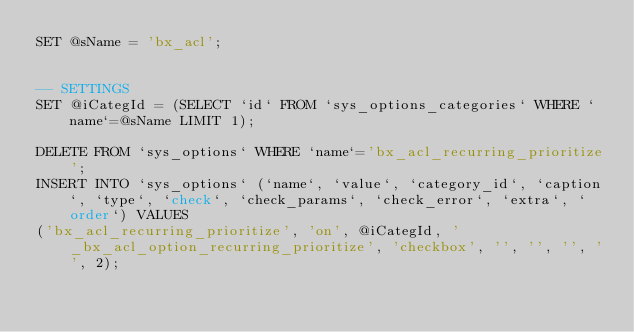Convert code to text. <code><loc_0><loc_0><loc_500><loc_500><_SQL_>SET @sName = 'bx_acl';


-- SETTINGS
SET @iCategId = (SELECT `id` FROM `sys_options_categories` WHERE `name`=@sName LIMIT 1);

DELETE FROM `sys_options` WHERE `name`='bx_acl_recurring_prioritize';
INSERT INTO `sys_options` (`name`, `value`, `category_id`, `caption`, `type`, `check`, `check_params`, `check_error`, `extra`, `order`) VALUES
('bx_acl_recurring_prioritize', 'on', @iCategId, '_bx_acl_option_recurring_prioritize', 'checkbox', '', '', '', '', 2);
</code> 